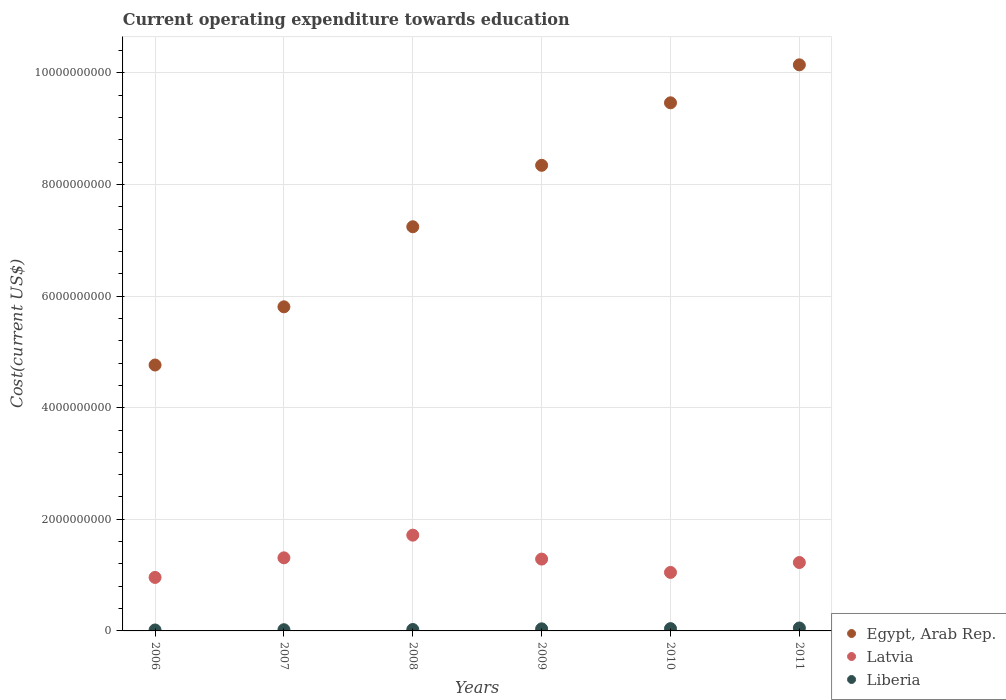How many different coloured dotlines are there?
Keep it short and to the point. 3. Is the number of dotlines equal to the number of legend labels?
Make the answer very short. Yes. What is the expenditure towards education in Egypt, Arab Rep. in 2009?
Make the answer very short. 8.34e+09. Across all years, what is the maximum expenditure towards education in Liberia?
Provide a succinct answer. 5.26e+07. Across all years, what is the minimum expenditure towards education in Latvia?
Keep it short and to the point. 9.59e+08. What is the total expenditure towards education in Liberia in the graph?
Your answer should be compact. 1.95e+08. What is the difference between the expenditure towards education in Latvia in 2007 and that in 2011?
Your answer should be very brief. 8.39e+07. What is the difference between the expenditure towards education in Egypt, Arab Rep. in 2009 and the expenditure towards education in Liberia in 2007?
Provide a short and direct response. 8.32e+09. What is the average expenditure towards education in Egypt, Arab Rep. per year?
Provide a succinct answer. 7.63e+09. In the year 2011, what is the difference between the expenditure towards education in Egypt, Arab Rep. and expenditure towards education in Latvia?
Provide a succinct answer. 8.92e+09. In how many years, is the expenditure towards education in Egypt, Arab Rep. greater than 6800000000 US$?
Your answer should be compact. 4. What is the ratio of the expenditure towards education in Latvia in 2009 to that in 2011?
Your answer should be compact. 1.05. Is the difference between the expenditure towards education in Egypt, Arab Rep. in 2006 and 2008 greater than the difference between the expenditure towards education in Latvia in 2006 and 2008?
Provide a short and direct response. No. What is the difference between the highest and the second highest expenditure towards education in Latvia?
Make the answer very short. 4.06e+08. What is the difference between the highest and the lowest expenditure towards education in Egypt, Arab Rep.?
Keep it short and to the point. 5.38e+09. In how many years, is the expenditure towards education in Egypt, Arab Rep. greater than the average expenditure towards education in Egypt, Arab Rep. taken over all years?
Keep it short and to the point. 3. Is the sum of the expenditure towards education in Egypt, Arab Rep. in 2006 and 2008 greater than the maximum expenditure towards education in Latvia across all years?
Give a very brief answer. Yes. Does the expenditure towards education in Liberia monotonically increase over the years?
Your response must be concise. Yes. Is the expenditure towards education in Egypt, Arab Rep. strictly less than the expenditure towards education in Latvia over the years?
Your response must be concise. No. How many dotlines are there?
Ensure brevity in your answer.  3. How many years are there in the graph?
Your response must be concise. 6. Does the graph contain any zero values?
Your answer should be compact. No. Where does the legend appear in the graph?
Your answer should be compact. Bottom right. How are the legend labels stacked?
Your response must be concise. Vertical. What is the title of the graph?
Provide a succinct answer. Current operating expenditure towards education. Does "Haiti" appear as one of the legend labels in the graph?
Your answer should be very brief. No. What is the label or title of the X-axis?
Ensure brevity in your answer.  Years. What is the label or title of the Y-axis?
Give a very brief answer. Cost(current US$). What is the Cost(current US$) of Egypt, Arab Rep. in 2006?
Provide a short and direct response. 4.76e+09. What is the Cost(current US$) of Latvia in 2006?
Give a very brief answer. 9.59e+08. What is the Cost(current US$) of Liberia in 2006?
Offer a very short reply. 1.70e+07. What is the Cost(current US$) of Egypt, Arab Rep. in 2007?
Your answer should be compact. 5.81e+09. What is the Cost(current US$) of Latvia in 2007?
Your response must be concise. 1.31e+09. What is the Cost(current US$) of Liberia in 2007?
Ensure brevity in your answer.  2.18e+07. What is the Cost(current US$) in Egypt, Arab Rep. in 2008?
Provide a succinct answer. 7.24e+09. What is the Cost(current US$) in Latvia in 2008?
Offer a very short reply. 1.72e+09. What is the Cost(current US$) of Liberia in 2008?
Your response must be concise. 2.55e+07. What is the Cost(current US$) in Egypt, Arab Rep. in 2009?
Offer a terse response. 8.34e+09. What is the Cost(current US$) of Latvia in 2009?
Provide a succinct answer. 1.29e+09. What is the Cost(current US$) in Liberia in 2009?
Your answer should be compact. 3.74e+07. What is the Cost(current US$) in Egypt, Arab Rep. in 2010?
Your response must be concise. 9.46e+09. What is the Cost(current US$) of Latvia in 2010?
Your answer should be compact. 1.05e+09. What is the Cost(current US$) of Liberia in 2010?
Ensure brevity in your answer.  4.12e+07. What is the Cost(current US$) in Egypt, Arab Rep. in 2011?
Ensure brevity in your answer.  1.01e+1. What is the Cost(current US$) in Latvia in 2011?
Provide a short and direct response. 1.23e+09. What is the Cost(current US$) of Liberia in 2011?
Ensure brevity in your answer.  5.26e+07. Across all years, what is the maximum Cost(current US$) of Egypt, Arab Rep.?
Your answer should be very brief. 1.01e+1. Across all years, what is the maximum Cost(current US$) in Latvia?
Provide a succinct answer. 1.72e+09. Across all years, what is the maximum Cost(current US$) of Liberia?
Provide a succinct answer. 5.26e+07. Across all years, what is the minimum Cost(current US$) in Egypt, Arab Rep.?
Give a very brief answer. 4.76e+09. Across all years, what is the minimum Cost(current US$) of Latvia?
Offer a terse response. 9.59e+08. Across all years, what is the minimum Cost(current US$) of Liberia?
Offer a very short reply. 1.70e+07. What is the total Cost(current US$) in Egypt, Arab Rep. in the graph?
Your answer should be very brief. 4.58e+1. What is the total Cost(current US$) of Latvia in the graph?
Your answer should be compact. 7.55e+09. What is the total Cost(current US$) of Liberia in the graph?
Offer a very short reply. 1.95e+08. What is the difference between the Cost(current US$) of Egypt, Arab Rep. in 2006 and that in 2007?
Keep it short and to the point. -1.04e+09. What is the difference between the Cost(current US$) of Latvia in 2006 and that in 2007?
Provide a short and direct response. -3.51e+08. What is the difference between the Cost(current US$) of Liberia in 2006 and that in 2007?
Keep it short and to the point. -4.82e+06. What is the difference between the Cost(current US$) in Egypt, Arab Rep. in 2006 and that in 2008?
Your response must be concise. -2.48e+09. What is the difference between the Cost(current US$) of Latvia in 2006 and that in 2008?
Provide a short and direct response. -7.57e+08. What is the difference between the Cost(current US$) of Liberia in 2006 and that in 2008?
Your answer should be compact. -8.56e+06. What is the difference between the Cost(current US$) in Egypt, Arab Rep. in 2006 and that in 2009?
Offer a very short reply. -3.58e+09. What is the difference between the Cost(current US$) in Latvia in 2006 and that in 2009?
Keep it short and to the point. -3.28e+08. What is the difference between the Cost(current US$) in Liberia in 2006 and that in 2009?
Give a very brief answer. -2.04e+07. What is the difference between the Cost(current US$) of Egypt, Arab Rep. in 2006 and that in 2010?
Your answer should be very brief. -4.70e+09. What is the difference between the Cost(current US$) of Latvia in 2006 and that in 2010?
Make the answer very short. -8.95e+07. What is the difference between the Cost(current US$) in Liberia in 2006 and that in 2010?
Provide a short and direct response. -2.42e+07. What is the difference between the Cost(current US$) in Egypt, Arab Rep. in 2006 and that in 2011?
Your answer should be compact. -5.38e+09. What is the difference between the Cost(current US$) in Latvia in 2006 and that in 2011?
Your response must be concise. -2.67e+08. What is the difference between the Cost(current US$) of Liberia in 2006 and that in 2011?
Provide a short and direct response. -3.56e+07. What is the difference between the Cost(current US$) of Egypt, Arab Rep. in 2007 and that in 2008?
Your answer should be compact. -1.43e+09. What is the difference between the Cost(current US$) in Latvia in 2007 and that in 2008?
Offer a terse response. -4.06e+08. What is the difference between the Cost(current US$) of Liberia in 2007 and that in 2008?
Ensure brevity in your answer.  -3.74e+06. What is the difference between the Cost(current US$) of Egypt, Arab Rep. in 2007 and that in 2009?
Your answer should be compact. -2.54e+09. What is the difference between the Cost(current US$) in Latvia in 2007 and that in 2009?
Provide a short and direct response. 2.25e+07. What is the difference between the Cost(current US$) of Liberia in 2007 and that in 2009?
Offer a terse response. -1.56e+07. What is the difference between the Cost(current US$) in Egypt, Arab Rep. in 2007 and that in 2010?
Offer a terse response. -3.66e+09. What is the difference between the Cost(current US$) of Latvia in 2007 and that in 2010?
Give a very brief answer. 2.61e+08. What is the difference between the Cost(current US$) in Liberia in 2007 and that in 2010?
Offer a very short reply. -1.94e+07. What is the difference between the Cost(current US$) of Egypt, Arab Rep. in 2007 and that in 2011?
Offer a very short reply. -4.34e+09. What is the difference between the Cost(current US$) in Latvia in 2007 and that in 2011?
Provide a succinct answer. 8.39e+07. What is the difference between the Cost(current US$) of Liberia in 2007 and that in 2011?
Your answer should be compact. -3.08e+07. What is the difference between the Cost(current US$) in Egypt, Arab Rep. in 2008 and that in 2009?
Provide a short and direct response. -1.10e+09. What is the difference between the Cost(current US$) in Latvia in 2008 and that in 2009?
Your response must be concise. 4.29e+08. What is the difference between the Cost(current US$) of Liberia in 2008 and that in 2009?
Keep it short and to the point. -1.18e+07. What is the difference between the Cost(current US$) in Egypt, Arab Rep. in 2008 and that in 2010?
Offer a very short reply. -2.22e+09. What is the difference between the Cost(current US$) of Latvia in 2008 and that in 2010?
Offer a very short reply. 6.68e+08. What is the difference between the Cost(current US$) of Liberia in 2008 and that in 2010?
Keep it short and to the point. -1.56e+07. What is the difference between the Cost(current US$) of Egypt, Arab Rep. in 2008 and that in 2011?
Your answer should be compact. -2.90e+09. What is the difference between the Cost(current US$) in Latvia in 2008 and that in 2011?
Provide a succinct answer. 4.90e+08. What is the difference between the Cost(current US$) in Liberia in 2008 and that in 2011?
Make the answer very short. -2.70e+07. What is the difference between the Cost(current US$) of Egypt, Arab Rep. in 2009 and that in 2010?
Your response must be concise. -1.12e+09. What is the difference between the Cost(current US$) of Latvia in 2009 and that in 2010?
Give a very brief answer. 2.39e+08. What is the difference between the Cost(current US$) in Liberia in 2009 and that in 2010?
Your answer should be compact. -3.80e+06. What is the difference between the Cost(current US$) of Egypt, Arab Rep. in 2009 and that in 2011?
Offer a very short reply. -1.80e+09. What is the difference between the Cost(current US$) in Latvia in 2009 and that in 2011?
Ensure brevity in your answer.  6.14e+07. What is the difference between the Cost(current US$) in Liberia in 2009 and that in 2011?
Provide a succinct answer. -1.52e+07. What is the difference between the Cost(current US$) of Egypt, Arab Rep. in 2010 and that in 2011?
Give a very brief answer. -6.80e+08. What is the difference between the Cost(current US$) in Latvia in 2010 and that in 2011?
Your answer should be very brief. -1.77e+08. What is the difference between the Cost(current US$) in Liberia in 2010 and that in 2011?
Provide a succinct answer. -1.14e+07. What is the difference between the Cost(current US$) of Egypt, Arab Rep. in 2006 and the Cost(current US$) of Latvia in 2007?
Make the answer very short. 3.45e+09. What is the difference between the Cost(current US$) of Egypt, Arab Rep. in 2006 and the Cost(current US$) of Liberia in 2007?
Your answer should be very brief. 4.74e+09. What is the difference between the Cost(current US$) in Latvia in 2006 and the Cost(current US$) in Liberia in 2007?
Give a very brief answer. 9.37e+08. What is the difference between the Cost(current US$) of Egypt, Arab Rep. in 2006 and the Cost(current US$) of Latvia in 2008?
Offer a terse response. 3.05e+09. What is the difference between the Cost(current US$) in Egypt, Arab Rep. in 2006 and the Cost(current US$) in Liberia in 2008?
Make the answer very short. 4.74e+09. What is the difference between the Cost(current US$) of Latvia in 2006 and the Cost(current US$) of Liberia in 2008?
Offer a very short reply. 9.33e+08. What is the difference between the Cost(current US$) of Egypt, Arab Rep. in 2006 and the Cost(current US$) of Latvia in 2009?
Your answer should be compact. 3.48e+09. What is the difference between the Cost(current US$) of Egypt, Arab Rep. in 2006 and the Cost(current US$) of Liberia in 2009?
Offer a terse response. 4.73e+09. What is the difference between the Cost(current US$) of Latvia in 2006 and the Cost(current US$) of Liberia in 2009?
Offer a very short reply. 9.21e+08. What is the difference between the Cost(current US$) in Egypt, Arab Rep. in 2006 and the Cost(current US$) in Latvia in 2010?
Your answer should be very brief. 3.72e+09. What is the difference between the Cost(current US$) of Egypt, Arab Rep. in 2006 and the Cost(current US$) of Liberia in 2010?
Give a very brief answer. 4.72e+09. What is the difference between the Cost(current US$) in Latvia in 2006 and the Cost(current US$) in Liberia in 2010?
Your answer should be very brief. 9.18e+08. What is the difference between the Cost(current US$) of Egypt, Arab Rep. in 2006 and the Cost(current US$) of Latvia in 2011?
Your answer should be very brief. 3.54e+09. What is the difference between the Cost(current US$) in Egypt, Arab Rep. in 2006 and the Cost(current US$) in Liberia in 2011?
Provide a succinct answer. 4.71e+09. What is the difference between the Cost(current US$) in Latvia in 2006 and the Cost(current US$) in Liberia in 2011?
Keep it short and to the point. 9.06e+08. What is the difference between the Cost(current US$) of Egypt, Arab Rep. in 2007 and the Cost(current US$) of Latvia in 2008?
Give a very brief answer. 4.09e+09. What is the difference between the Cost(current US$) of Egypt, Arab Rep. in 2007 and the Cost(current US$) of Liberia in 2008?
Give a very brief answer. 5.78e+09. What is the difference between the Cost(current US$) of Latvia in 2007 and the Cost(current US$) of Liberia in 2008?
Offer a terse response. 1.28e+09. What is the difference between the Cost(current US$) in Egypt, Arab Rep. in 2007 and the Cost(current US$) in Latvia in 2009?
Your response must be concise. 4.52e+09. What is the difference between the Cost(current US$) in Egypt, Arab Rep. in 2007 and the Cost(current US$) in Liberia in 2009?
Provide a succinct answer. 5.77e+09. What is the difference between the Cost(current US$) of Latvia in 2007 and the Cost(current US$) of Liberia in 2009?
Your answer should be very brief. 1.27e+09. What is the difference between the Cost(current US$) of Egypt, Arab Rep. in 2007 and the Cost(current US$) of Latvia in 2010?
Make the answer very short. 4.76e+09. What is the difference between the Cost(current US$) of Egypt, Arab Rep. in 2007 and the Cost(current US$) of Liberia in 2010?
Keep it short and to the point. 5.77e+09. What is the difference between the Cost(current US$) in Latvia in 2007 and the Cost(current US$) in Liberia in 2010?
Your response must be concise. 1.27e+09. What is the difference between the Cost(current US$) in Egypt, Arab Rep. in 2007 and the Cost(current US$) in Latvia in 2011?
Ensure brevity in your answer.  4.58e+09. What is the difference between the Cost(current US$) in Egypt, Arab Rep. in 2007 and the Cost(current US$) in Liberia in 2011?
Ensure brevity in your answer.  5.75e+09. What is the difference between the Cost(current US$) in Latvia in 2007 and the Cost(current US$) in Liberia in 2011?
Keep it short and to the point. 1.26e+09. What is the difference between the Cost(current US$) in Egypt, Arab Rep. in 2008 and the Cost(current US$) in Latvia in 2009?
Offer a very short reply. 5.95e+09. What is the difference between the Cost(current US$) of Egypt, Arab Rep. in 2008 and the Cost(current US$) of Liberia in 2009?
Offer a very short reply. 7.20e+09. What is the difference between the Cost(current US$) of Latvia in 2008 and the Cost(current US$) of Liberia in 2009?
Give a very brief answer. 1.68e+09. What is the difference between the Cost(current US$) in Egypt, Arab Rep. in 2008 and the Cost(current US$) in Latvia in 2010?
Your answer should be very brief. 6.19e+09. What is the difference between the Cost(current US$) in Egypt, Arab Rep. in 2008 and the Cost(current US$) in Liberia in 2010?
Provide a succinct answer. 7.20e+09. What is the difference between the Cost(current US$) in Latvia in 2008 and the Cost(current US$) in Liberia in 2010?
Offer a very short reply. 1.67e+09. What is the difference between the Cost(current US$) of Egypt, Arab Rep. in 2008 and the Cost(current US$) of Latvia in 2011?
Provide a succinct answer. 6.02e+09. What is the difference between the Cost(current US$) in Egypt, Arab Rep. in 2008 and the Cost(current US$) in Liberia in 2011?
Ensure brevity in your answer.  7.19e+09. What is the difference between the Cost(current US$) of Latvia in 2008 and the Cost(current US$) of Liberia in 2011?
Your response must be concise. 1.66e+09. What is the difference between the Cost(current US$) of Egypt, Arab Rep. in 2009 and the Cost(current US$) of Latvia in 2010?
Your answer should be very brief. 7.29e+09. What is the difference between the Cost(current US$) in Egypt, Arab Rep. in 2009 and the Cost(current US$) in Liberia in 2010?
Your response must be concise. 8.30e+09. What is the difference between the Cost(current US$) of Latvia in 2009 and the Cost(current US$) of Liberia in 2010?
Provide a short and direct response. 1.25e+09. What is the difference between the Cost(current US$) in Egypt, Arab Rep. in 2009 and the Cost(current US$) in Latvia in 2011?
Give a very brief answer. 7.12e+09. What is the difference between the Cost(current US$) in Egypt, Arab Rep. in 2009 and the Cost(current US$) in Liberia in 2011?
Your answer should be very brief. 8.29e+09. What is the difference between the Cost(current US$) of Latvia in 2009 and the Cost(current US$) of Liberia in 2011?
Give a very brief answer. 1.23e+09. What is the difference between the Cost(current US$) in Egypt, Arab Rep. in 2010 and the Cost(current US$) in Latvia in 2011?
Offer a very short reply. 8.24e+09. What is the difference between the Cost(current US$) of Egypt, Arab Rep. in 2010 and the Cost(current US$) of Liberia in 2011?
Make the answer very short. 9.41e+09. What is the difference between the Cost(current US$) of Latvia in 2010 and the Cost(current US$) of Liberia in 2011?
Offer a terse response. 9.96e+08. What is the average Cost(current US$) in Egypt, Arab Rep. per year?
Give a very brief answer. 7.63e+09. What is the average Cost(current US$) of Latvia per year?
Provide a succinct answer. 1.26e+09. What is the average Cost(current US$) of Liberia per year?
Ensure brevity in your answer.  3.26e+07. In the year 2006, what is the difference between the Cost(current US$) of Egypt, Arab Rep. and Cost(current US$) of Latvia?
Offer a terse response. 3.81e+09. In the year 2006, what is the difference between the Cost(current US$) of Egypt, Arab Rep. and Cost(current US$) of Liberia?
Your response must be concise. 4.75e+09. In the year 2006, what is the difference between the Cost(current US$) in Latvia and Cost(current US$) in Liberia?
Your answer should be compact. 9.42e+08. In the year 2007, what is the difference between the Cost(current US$) of Egypt, Arab Rep. and Cost(current US$) of Latvia?
Make the answer very short. 4.50e+09. In the year 2007, what is the difference between the Cost(current US$) of Egypt, Arab Rep. and Cost(current US$) of Liberia?
Your response must be concise. 5.79e+09. In the year 2007, what is the difference between the Cost(current US$) in Latvia and Cost(current US$) in Liberia?
Keep it short and to the point. 1.29e+09. In the year 2008, what is the difference between the Cost(current US$) of Egypt, Arab Rep. and Cost(current US$) of Latvia?
Keep it short and to the point. 5.53e+09. In the year 2008, what is the difference between the Cost(current US$) of Egypt, Arab Rep. and Cost(current US$) of Liberia?
Offer a very short reply. 7.22e+09. In the year 2008, what is the difference between the Cost(current US$) of Latvia and Cost(current US$) of Liberia?
Give a very brief answer. 1.69e+09. In the year 2009, what is the difference between the Cost(current US$) of Egypt, Arab Rep. and Cost(current US$) of Latvia?
Offer a very short reply. 7.06e+09. In the year 2009, what is the difference between the Cost(current US$) in Egypt, Arab Rep. and Cost(current US$) in Liberia?
Make the answer very short. 8.31e+09. In the year 2009, what is the difference between the Cost(current US$) in Latvia and Cost(current US$) in Liberia?
Your response must be concise. 1.25e+09. In the year 2010, what is the difference between the Cost(current US$) in Egypt, Arab Rep. and Cost(current US$) in Latvia?
Your response must be concise. 8.41e+09. In the year 2010, what is the difference between the Cost(current US$) in Egypt, Arab Rep. and Cost(current US$) in Liberia?
Ensure brevity in your answer.  9.42e+09. In the year 2010, what is the difference between the Cost(current US$) in Latvia and Cost(current US$) in Liberia?
Your response must be concise. 1.01e+09. In the year 2011, what is the difference between the Cost(current US$) in Egypt, Arab Rep. and Cost(current US$) in Latvia?
Offer a very short reply. 8.92e+09. In the year 2011, what is the difference between the Cost(current US$) in Egypt, Arab Rep. and Cost(current US$) in Liberia?
Give a very brief answer. 1.01e+1. In the year 2011, what is the difference between the Cost(current US$) in Latvia and Cost(current US$) in Liberia?
Ensure brevity in your answer.  1.17e+09. What is the ratio of the Cost(current US$) in Egypt, Arab Rep. in 2006 to that in 2007?
Provide a succinct answer. 0.82. What is the ratio of the Cost(current US$) in Latvia in 2006 to that in 2007?
Give a very brief answer. 0.73. What is the ratio of the Cost(current US$) of Liberia in 2006 to that in 2007?
Offer a very short reply. 0.78. What is the ratio of the Cost(current US$) of Egypt, Arab Rep. in 2006 to that in 2008?
Your answer should be very brief. 0.66. What is the ratio of the Cost(current US$) of Latvia in 2006 to that in 2008?
Your answer should be very brief. 0.56. What is the ratio of the Cost(current US$) of Liberia in 2006 to that in 2008?
Your answer should be compact. 0.66. What is the ratio of the Cost(current US$) in Egypt, Arab Rep. in 2006 to that in 2009?
Keep it short and to the point. 0.57. What is the ratio of the Cost(current US$) in Latvia in 2006 to that in 2009?
Offer a very short reply. 0.74. What is the ratio of the Cost(current US$) of Liberia in 2006 to that in 2009?
Provide a short and direct response. 0.45. What is the ratio of the Cost(current US$) of Egypt, Arab Rep. in 2006 to that in 2010?
Make the answer very short. 0.5. What is the ratio of the Cost(current US$) in Latvia in 2006 to that in 2010?
Offer a terse response. 0.91. What is the ratio of the Cost(current US$) in Liberia in 2006 to that in 2010?
Offer a very short reply. 0.41. What is the ratio of the Cost(current US$) of Egypt, Arab Rep. in 2006 to that in 2011?
Keep it short and to the point. 0.47. What is the ratio of the Cost(current US$) in Latvia in 2006 to that in 2011?
Your answer should be very brief. 0.78. What is the ratio of the Cost(current US$) in Liberia in 2006 to that in 2011?
Provide a short and direct response. 0.32. What is the ratio of the Cost(current US$) of Egypt, Arab Rep. in 2007 to that in 2008?
Make the answer very short. 0.8. What is the ratio of the Cost(current US$) in Latvia in 2007 to that in 2008?
Your answer should be compact. 0.76. What is the ratio of the Cost(current US$) in Liberia in 2007 to that in 2008?
Your answer should be very brief. 0.85. What is the ratio of the Cost(current US$) in Egypt, Arab Rep. in 2007 to that in 2009?
Ensure brevity in your answer.  0.7. What is the ratio of the Cost(current US$) of Latvia in 2007 to that in 2009?
Offer a terse response. 1.02. What is the ratio of the Cost(current US$) in Liberia in 2007 to that in 2009?
Make the answer very short. 0.58. What is the ratio of the Cost(current US$) in Egypt, Arab Rep. in 2007 to that in 2010?
Your answer should be very brief. 0.61. What is the ratio of the Cost(current US$) in Latvia in 2007 to that in 2010?
Your response must be concise. 1.25. What is the ratio of the Cost(current US$) in Liberia in 2007 to that in 2010?
Offer a terse response. 0.53. What is the ratio of the Cost(current US$) of Egypt, Arab Rep. in 2007 to that in 2011?
Keep it short and to the point. 0.57. What is the ratio of the Cost(current US$) in Latvia in 2007 to that in 2011?
Keep it short and to the point. 1.07. What is the ratio of the Cost(current US$) in Liberia in 2007 to that in 2011?
Your answer should be very brief. 0.41. What is the ratio of the Cost(current US$) of Egypt, Arab Rep. in 2008 to that in 2009?
Give a very brief answer. 0.87. What is the ratio of the Cost(current US$) of Latvia in 2008 to that in 2009?
Ensure brevity in your answer.  1.33. What is the ratio of the Cost(current US$) in Liberia in 2008 to that in 2009?
Provide a succinct answer. 0.68. What is the ratio of the Cost(current US$) of Egypt, Arab Rep. in 2008 to that in 2010?
Keep it short and to the point. 0.77. What is the ratio of the Cost(current US$) in Latvia in 2008 to that in 2010?
Provide a succinct answer. 1.64. What is the ratio of the Cost(current US$) of Liberia in 2008 to that in 2010?
Your response must be concise. 0.62. What is the ratio of the Cost(current US$) in Egypt, Arab Rep. in 2008 to that in 2011?
Your answer should be compact. 0.71. What is the ratio of the Cost(current US$) of Liberia in 2008 to that in 2011?
Ensure brevity in your answer.  0.49. What is the ratio of the Cost(current US$) of Egypt, Arab Rep. in 2009 to that in 2010?
Keep it short and to the point. 0.88. What is the ratio of the Cost(current US$) in Latvia in 2009 to that in 2010?
Your response must be concise. 1.23. What is the ratio of the Cost(current US$) of Liberia in 2009 to that in 2010?
Provide a short and direct response. 0.91. What is the ratio of the Cost(current US$) of Egypt, Arab Rep. in 2009 to that in 2011?
Offer a terse response. 0.82. What is the ratio of the Cost(current US$) of Latvia in 2009 to that in 2011?
Offer a terse response. 1.05. What is the ratio of the Cost(current US$) of Liberia in 2009 to that in 2011?
Provide a short and direct response. 0.71. What is the ratio of the Cost(current US$) of Egypt, Arab Rep. in 2010 to that in 2011?
Give a very brief answer. 0.93. What is the ratio of the Cost(current US$) in Latvia in 2010 to that in 2011?
Offer a very short reply. 0.86. What is the ratio of the Cost(current US$) of Liberia in 2010 to that in 2011?
Your response must be concise. 0.78. What is the difference between the highest and the second highest Cost(current US$) in Egypt, Arab Rep.?
Ensure brevity in your answer.  6.80e+08. What is the difference between the highest and the second highest Cost(current US$) of Latvia?
Offer a very short reply. 4.06e+08. What is the difference between the highest and the second highest Cost(current US$) of Liberia?
Offer a very short reply. 1.14e+07. What is the difference between the highest and the lowest Cost(current US$) of Egypt, Arab Rep.?
Offer a very short reply. 5.38e+09. What is the difference between the highest and the lowest Cost(current US$) of Latvia?
Offer a very short reply. 7.57e+08. What is the difference between the highest and the lowest Cost(current US$) of Liberia?
Your answer should be compact. 3.56e+07. 